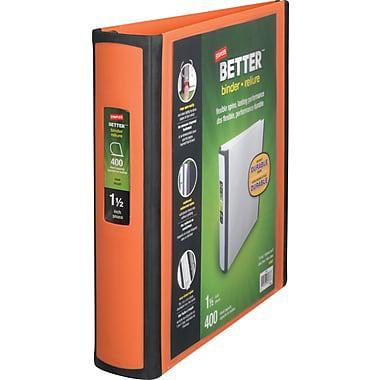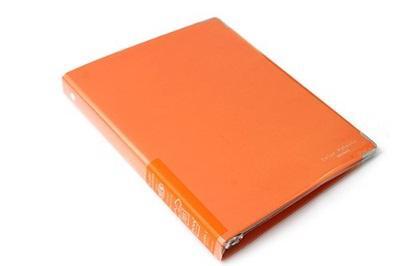The first image is the image on the left, the second image is the image on the right. Given the left and right images, does the statement "An image shows a stack of at least eight binders that appears to sit on a flat surface." hold true? Answer yes or no. No. The first image is the image on the left, the second image is the image on the right. Assess this claim about the two images: "In one image, at least one orange notebook is closed and lying flat with the opening to the back, while the second image shows at least one notebook that is orange and black with no visible contents.". Correct or not? Answer yes or no. Yes. 